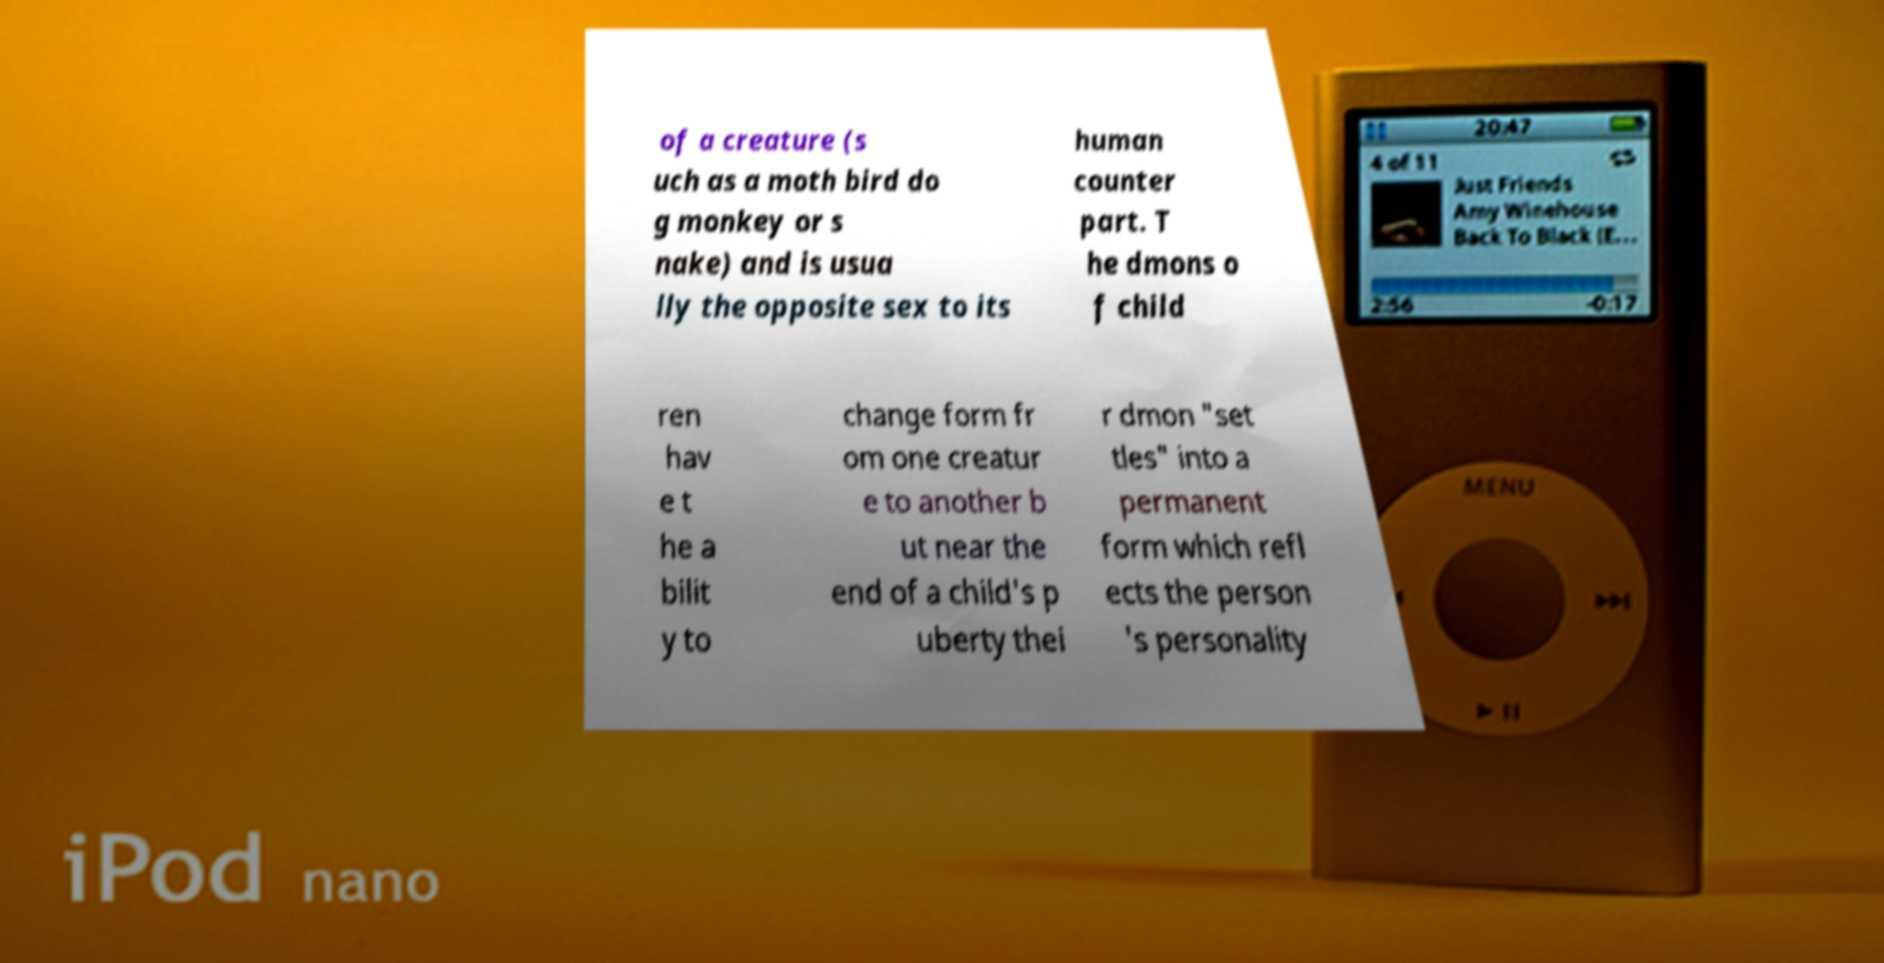For documentation purposes, I need the text within this image transcribed. Could you provide that? of a creature (s uch as a moth bird do g monkey or s nake) and is usua lly the opposite sex to its human counter part. T he dmons o f child ren hav e t he a bilit y to change form fr om one creatur e to another b ut near the end of a child's p uberty thei r dmon "set tles" into a permanent form which refl ects the person 's personality 